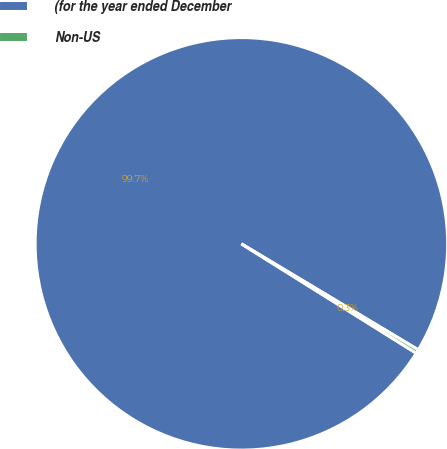Convert chart to OTSL. <chart><loc_0><loc_0><loc_500><loc_500><pie_chart><fcel>(for the year ended December<fcel>Non-US<nl><fcel>99.7%<fcel>0.3%<nl></chart> 